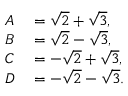Convert formula to latex. <formula><loc_0><loc_0><loc_500><loc_500>\begin{array} { r l } { A } & = { \sqrt { 2 } } + { \sqrt { 3 } } , } \\ { B } & = { \sqrt { 2 } } - { \sqrt { 3 } } , } \\ { C } & = - { \sqrt { 2 } } + { \sqrt { 3 } } , } \\ { D } & = - { \sqrt { 2 } } - { \sqrt { 3 } } . } \end{array}</formula> 